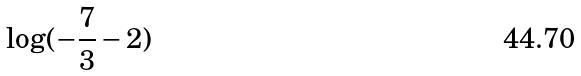<formula> <loc_0><loc_0><loc_500><loc_500>\log ( - \frac { 7 } { 3 } - 2 )</formula> 